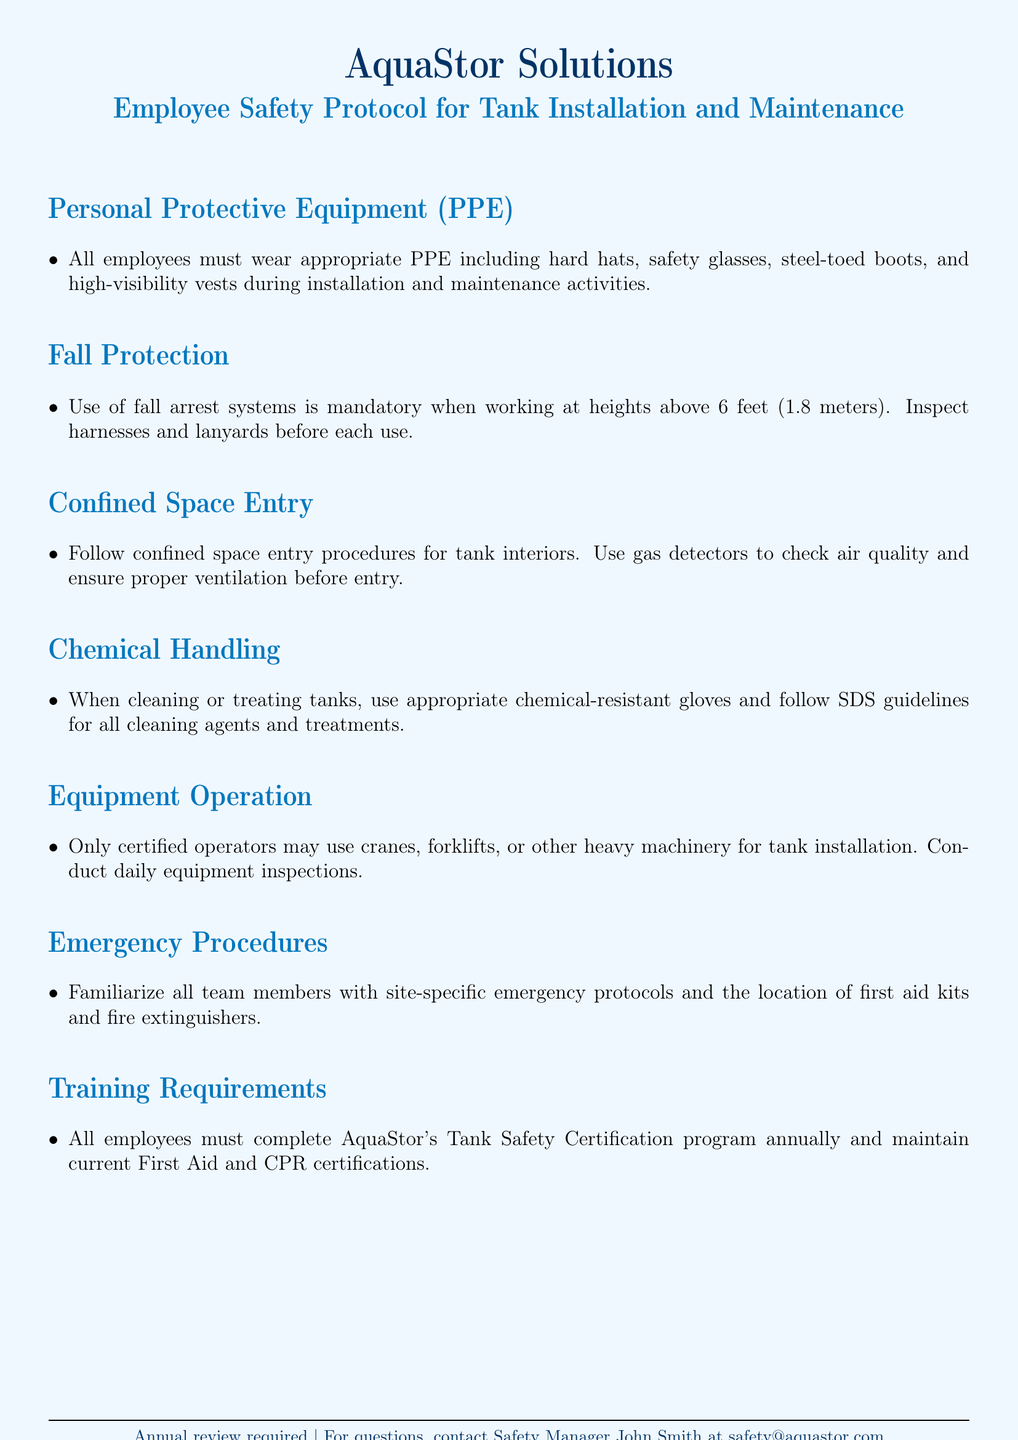What is the required PPE? The required PPE includes hard hats, safety glasses, steel-toed boots, and high-visibility vests during installation and maintenance activities.
Answer: hard hats, safety glasses, steel-toed boots, high-visibility vests What is the height threshold for mandatory fall protection? The height threshold above which fall arrest systems are mandatory is specified in the document.
Answer: 6 feet What must be used to check air quality before entering a confined space? The document states that specific tools are necessary to ensure safety while entering confined spaces.
Answer: gas detectors Who must operate cranes and heavy machinery? The document specifies a requirement regarding the qualifications of personnel operating certain equipment.
Answer: certified operators How often must employees complete the Tank Safety Certification program? The frequency of completing this certification is indicated in the training requirements section of the document.
Answer: annually What should team members familiarize themselves with on site? The emergency procedures section highlights specific knowledge that all team members should acquire.
Answer: site-specific emergency protocols What type of gloves should be used for chemical handling? The document outlines appropriate gear for handling chemicals, emphasizing a specific type of glove.
Answer: chemical-resistant gloves What is the main purpose of the Employee Safety Protocol document? The focus of the document is on safety guidelines related to a specific work context.
Answer: safety protocols 